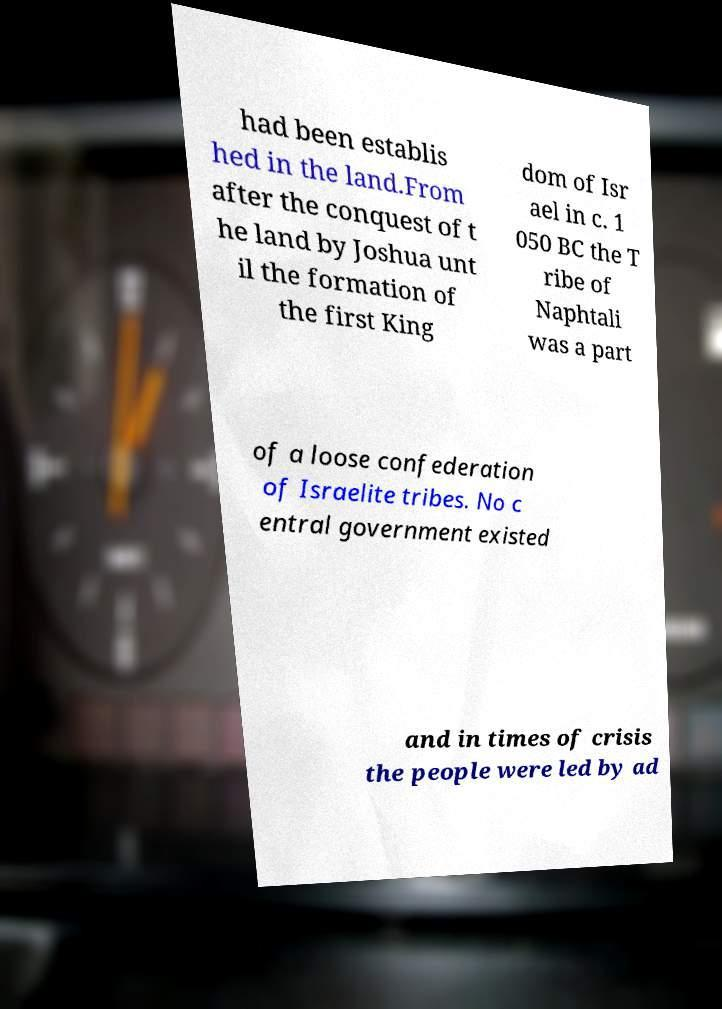For documentation purposes, I need the text within this image transcribed. Could you provide that? had been establis hed in the land.From after the conquest of t he land by Joshua unt il the formation of the first King dom of Isr ael in c. 1 050 BC the T ribe of Naphtali was a part of a loose confederation of Israelite tribes. No c entral government existed and in times of crisis the people were led by ad 